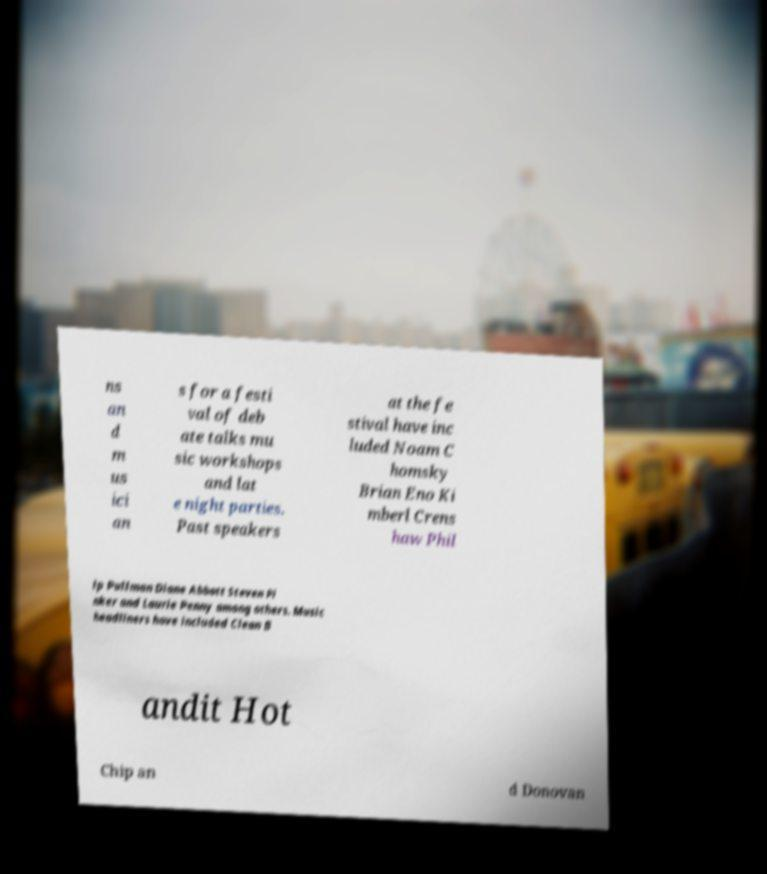Can you read and provide the text displayed in the image?This photo seems to have some interesting text. Can you extract and type it out for me? ns an d m us ici an s for a festi val of deb ate talks mu sic workshops and lat e night parties. Past speakers at the fe stival have inc luded Noam C homsky Brian Eno Ki mberl Crens haw Phil ip Pullman Diane Abbott Steven Pi nker and Laurie Penny among others. Music headliners have included Clean B andit Hot Chip an d Donovan 